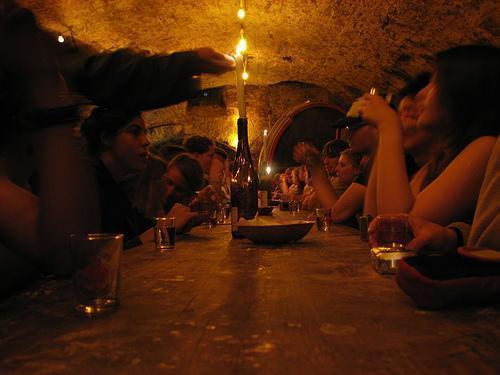How many people are there?
Give a very brief answer. 6. How many sheep is this?
Give a very brief answer. 0. 